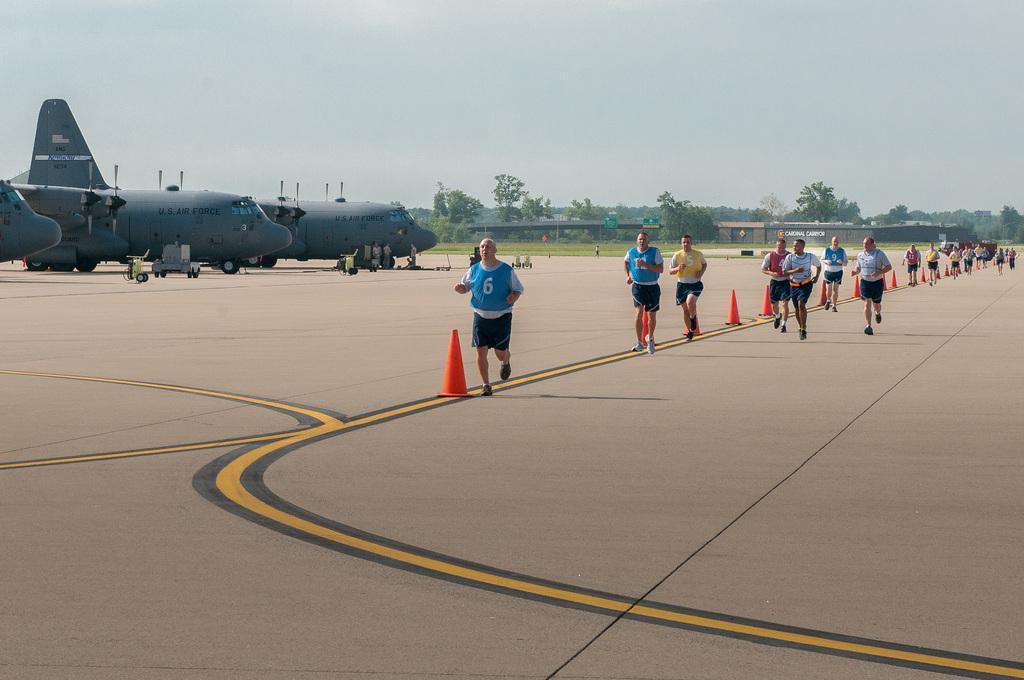Please provide a concise description of this image. In this image I can see on the right side a group of people are running, on the left side there are aeroplanes, at the back side there are trees and it looks like a bridge. At the top it is the sky. 